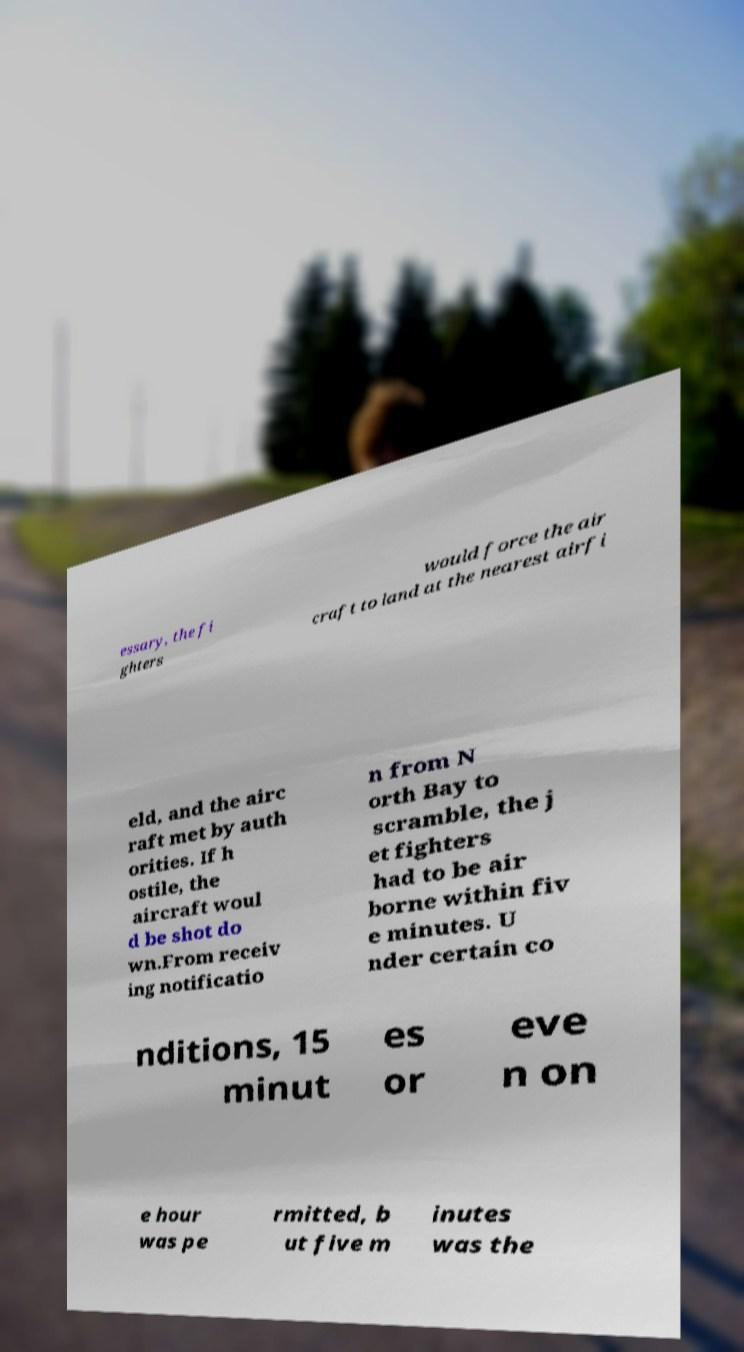Please identify and transcribe the text found in this image. essary, the fi ghters would force the air craft to land at the nearest airfi eld, and the airc raft met by auth orities. If h ostile, the aircraft woul d be shot do wn.From receiv ing notificatio n from N orth Bay to scramble, the j et fighters had to be air borne within fiv e minutes. U nder certain co nditions, 15 minut es or eve n on e hour was pe rmitted, b ut five m inutes was the 